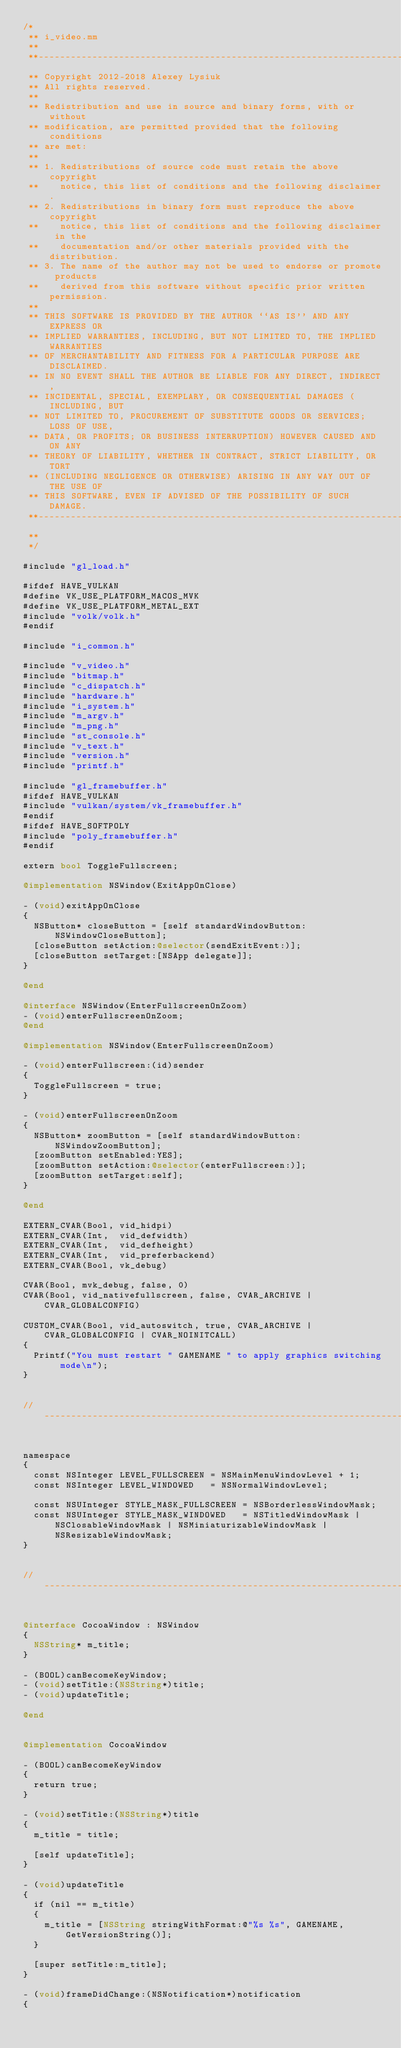Convert code to text. <code><loc_0><loc_0><loc_500><loc_500><_ObjectiveC_>/*
 ** i_video.mm
 **
 **---------------------------------------------------------------------------
 ** Copyright 2012-2018 Alexey Lysiuk
 ** All rights reserved.
 **
 ** Redistribution and use in source and binary forms, with or without
 ** modification, are permitted provided that the following conditions
 ** are met:
 **
 ** 1. Redistributions of source code must retain the above copyright
 **    notice, this list of conditions and the following disclaimer.
 ** 2. Redistributions in binary form must reproduce the above copyright
 **    notice, this list of conditions and the following disclaimer in the
 **    documentation and/or other materials provided with the distribution.
 ** 3. The name of the author may not be used to endorse or promote products
 **    derived from this software without specific prior written permission.
 **
 ** THIS SOFTWARE IS PROVIDED BY THE AUTHOR ``AS IS'' AND ANY EXPRESS OR
 ** IMPLIED WARRANTIES, INCLUDING, BUT NOT LIMITED TO, THE IMPLIED WARRANTIES
 ** OF MERCHANTABILITY AND FITNESS FOR A PARTICULAR PURPOSE ARE DISCLAIMED.
 ** IN NO EVENT SHALL THE AUTHOR BE LIABLE FOR ANY DIRECT, INDIRECT,
 ** INCIDENTAL, SPECIAL, EXEMPLARY, OR CONSEQUENTIAL DAMAGES (INCLUDING, BUT
 ** NOT LIMITED TO, PROCUREMENT OF SUBSTITUTE GOODS OR SERVICES; LOSS OF USE,
 ** DATA, OR PROFITS; OR BUSINESS INTERRUPTION) HOWEVER CAUSED AND ON ANY
 ** THEORY OF LIABILITY, WHETHER IN CONTRACT, STRICT LIABILITY, OR TORT
 ** (INCLUDING NEGLIGENCE OR OTHERWISE) ARISING IN ANY WAY OUT OF THE USE OF
 ** THIS SOFTWARE, EVEN IF ADVISED OF THE POSSIBILITY OF SUCH DAMAGE.
 **---------------------------------------------------------------------------
 **
 */

#include "gl_load.h"

#ifdef HAVE_VULKAN
#define VK_USE_PLATFORM_MACOS_MVK
#define VK_USE_PLATFORM_METAL_EXT
#include "volk/volk.h"
#endif

#include "i_common.h"

#include "v_video.h"
#include "bitmap.h"
#include "c_dispatch.h"
#include "hardware.h"
#include "i_system.h"
#include "m_argv.h"
#include "m_png.h"
#include "st_console.h"
#include "v_text.h"
#include "version.h"
#include "printf.h"

#include "gl_framebuffer.h"
#ifdef HAVE_VULKAN
#include "vulkan/system/vk_framebuffer.h"
#endif
#ifdef HAVE_SOFTPOLY
#include "poly_framebuffer.h"
#endif

extern bool ToggleFullscreen;

@implementation NSWindow(ExitAppOnClose)

- (void)exitAppOnClose
{
	NSButton* closeButton = [self standardWindowButton:NSWindowCloseButton];
	[closeButton setAction:@selector(sendExitEvent:)];
	[closeButton setTarget:[NSApp delegate]];
}

@end

@interface NSWindow(EnterFullscreenOnZoom)
- (void)enterFullscreenOnZoom;
@end

@implementation NSWindow(EnterFullscreenOnZoom)

- (void)enterFullscreen:(id)sender
{
	ToggleFullscreen = true;
}

- (void)enterFullscreenOnZoom
{
	NSButton* zoomButton = [self standardWindowButton:NSWindowZoomButton];
	[zoomButton setEnabled:YES];
	[zoomButton setAction:@selector(enterFullscreen:)];
	[zoomButton setTarget:self];
}

@end

EXTERN_CVAR(Bool, vid_hidpi)
EXTERN_CVAR(Int,  vid_defwidth)
EXTERN_CVAR(Int,  vid_defheight)
EXTERN_CVAR(Int,  vid_preferbackend)
EXTERN_CVAR(Bool, vk_debug)

CVAR(Bool, mvk_debug, false, 0)
CVAR(Bool, vid_nativefullscreen, false, CVAR_ARCHIVE | CVAR_GLOBALCONFIG)

CUSTOM_CVAR(Bool, vid_autoswitch, true, CVAR_ARCHIVE | CVAR_GLOBALCONFIG | CVAR_NOINITCALL)
{
	Printf("You must restart " GAMENAME " to apply graphics switching mode\n");
}


// ---------------------------------------------------------------------------


namespace
{
	const NSInteger LEVEL_FULLSCREEN = NSMainMenuWindowLevel + 1;
	const NSInteger LEVEL_WINDOWED   = NSNormalWindowLevel;

	const NSUInteger STYLE_MASK_FULLSCREEN = NSBorderlessWindowMask;
	const NSUInteger STYLE_MASK_WINDOWED   = NSTitledWindowMask | NSClosableWindowMask | NSMiniaturizableWindowMask | NSResizableWindowMask;
}


// ---------------------------------------------------------------------------


@interface CocoaWindow : NSWindow
{
	NSString* m_title;
}

- (BOOL)canBecomeKeyWindow;
- (void)setTitle:(NSString*)title;
- (void)updateTitle;

@end


@implementation CocoaWindow

- (BOOL)canBecomeKeyWindow
{
	return true;
}

- (void)setTitle:(NSString*)title
{
	m_title = title;

	[self updateTitle];
}

- (void)updateTitle
{
	if (nil == m_title)
	{
		m_title = [NSString stringWithFormat:@"%s %s", GAMENAME, GetVersionString()];
	}

	[super setTitle:m_title];
}

- (void)frameDidChange:(NSNotification*)notification
{</code> 